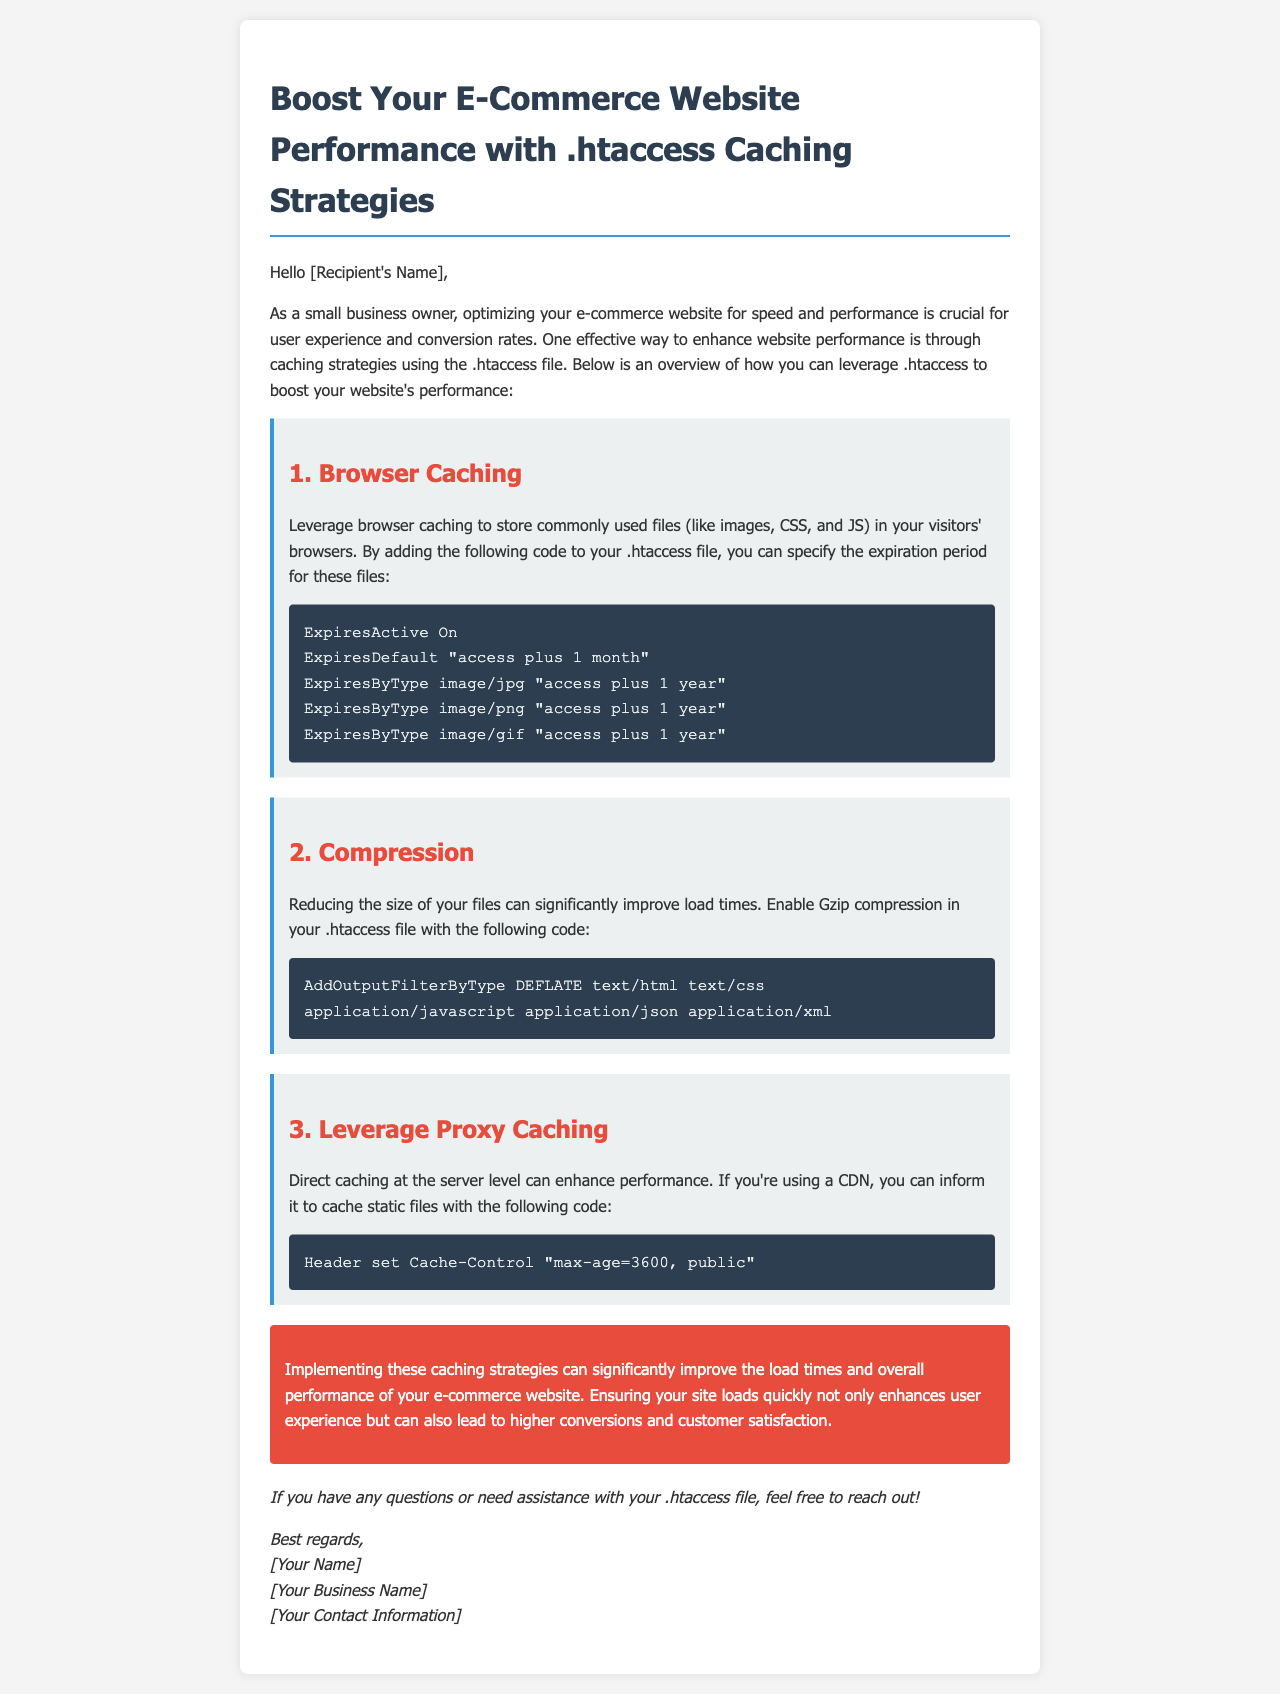What is the title of the email? The title of the email is located in the <title> tag in the head section of the document.
Answer: Boost Your E-Commerce Website Performance What caching strategy is mentioned first? The first caching strategy is clearly labeled in the email content section, indicating its order.
Answer: Browser Caching What is the expiration period for images in the browser caching strategy? The expiration period for images is provided in the specific code section under the Browser Caching strategy.
Answer: 1 year What type of compression is enabled in the document? The type of compression mentioned is specified in the compression section of the email.
Answer: Gzip How long does the Cache-Control header specify for proxy caching? The specific time is quoted in the proxy caching strategy section.
Answer: 3600 What is the purpose of enabling browser caching? The purpose is outlined in the introduction and the Browser Caching section.
Answer: Store commonly used files What background color is used for the conclusion section? The background color for the conclusion section is described in the email's styling section.
Answer: Red Who is the email intended for? The intended recipient is mentioned at the beginning of the document.
Answer: [Recipient's Name] What is the overall goal of implementing these strategies? The overall goal is summarized in the conclusion section of the email.
Answer: Improve load times and overall performance 